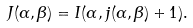Convert formula to latex. <formula><loc_0><loc_0><loc_500><loc_500>J ( { \alpha } , { \beta } ) = I ( { \alpha } , j ( { \alpha } , { \beta } ) + 1 ) .</formula> 